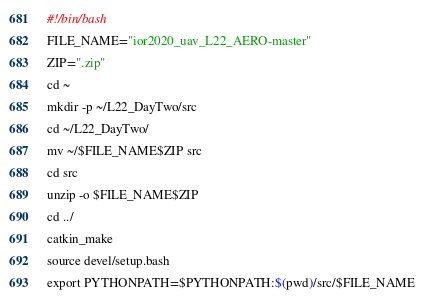<code> <loc_0><loc_0><loc_500><loc_500><_Bash_>#!/bin/bash
FILE_NAME="ior2020_uav_L22_AERO-master"
ZIP=".zip"
cd ~
mkdir -p ~/L22_DayTwo/src
cd ~/L22_DayTwo/
mv ~/$FILE_NAME$ZIP src
cd src
unzip -o $FILE_NAME$ZIP
cd ../
catkin_make
source devel/setup.bash
export PYTHONPATH=$PYTHONPATH:$(pwd)/src/$FILE_NAME</code> 